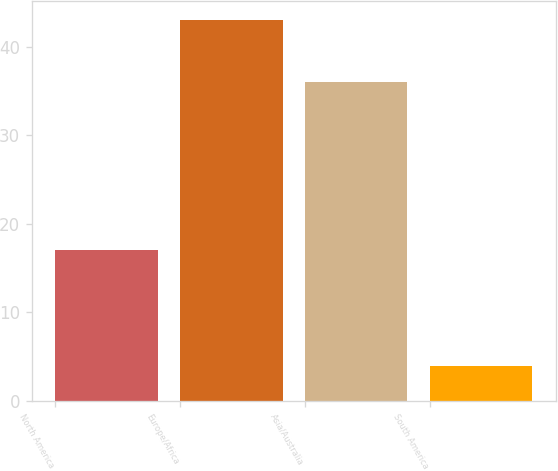Convert chart to OTSL. <chart><loc_0><loc_0><loc_500><loc_500><bar_chart><fcel>North America<fcel>Europe/Africa<fcel>Asia/Australia<fcel>South America<nl><fcel>17<fcel>43<fcel>36<fcel>4<nl></chart> 